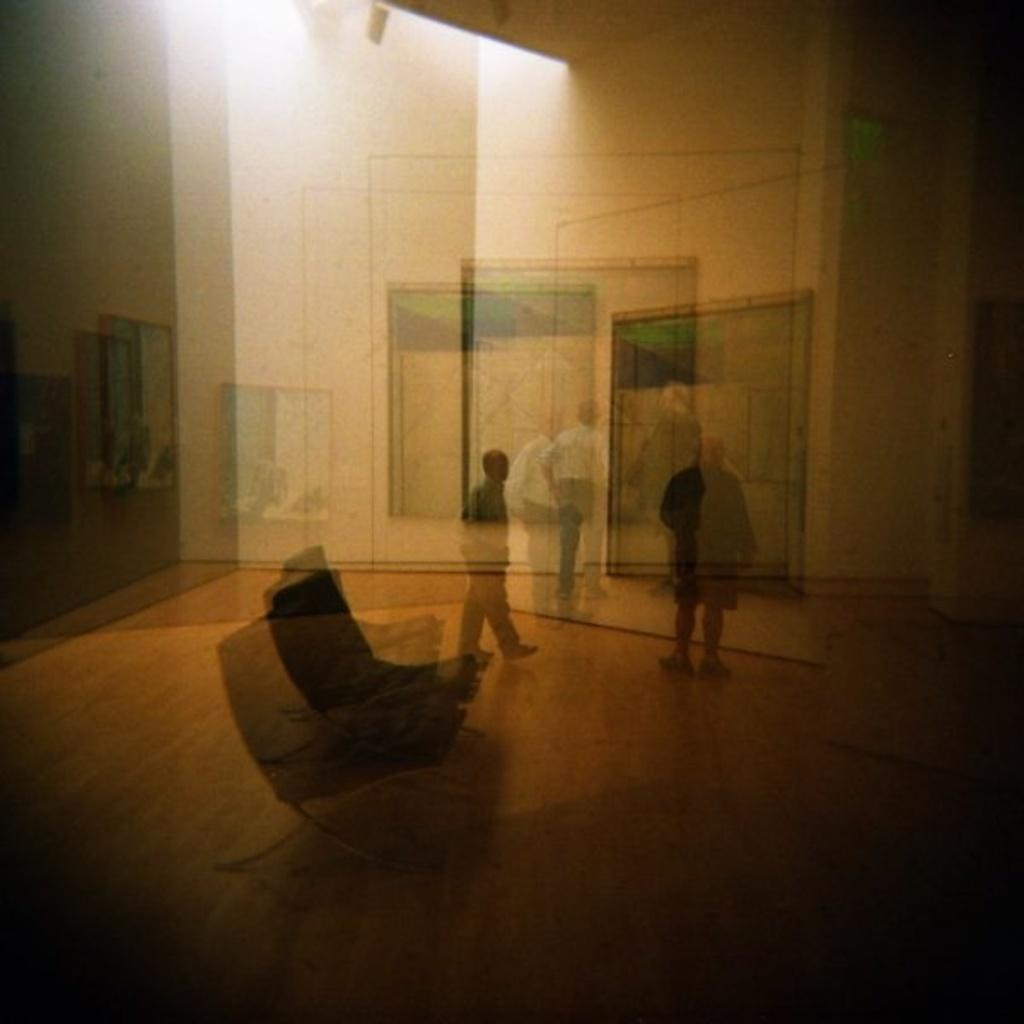Who or what can be seen in the image? There are people in the image. What piece of furniture is present in the image? There is a couch in the image. What type of decoration is on the wall in the image? There are frames on the wall in the image. What type of dinosaurs can be seen in the image? There are no dinosaurs present in the image. How does the behavior of the people in the image affect the air quality? The provided facts do not mention anything about the behavior of the people or the air quality, so it is not possible to answer this question based on the given information. 